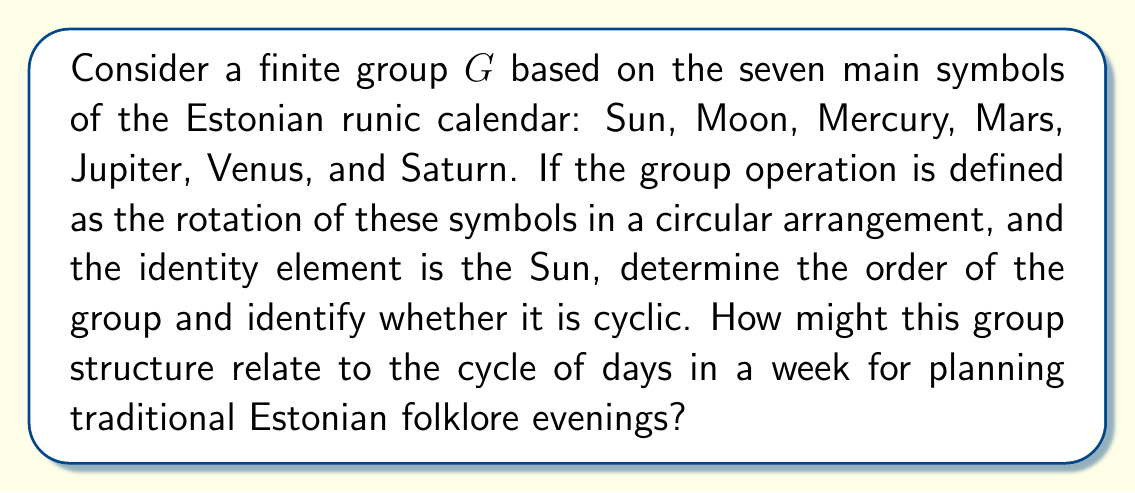Provide a solution to this math problem. To analyze this group structure:

1) First, we need to understand the elements of the group. We have 7 elements corresponding to the celestial bodies: 
   $G = \{Sun, Moon, Mercury, Mars, Jupiter, Venus, Saturn\}$

2) The group operation is rotation in a circular arrangement. This means that each element, when applied, shifts the arrangement by one position.

3) Let's define the generator of the group as $a$, where $a$ represents a single rotation. Then:
   $a^1 = Moon$
   $a^2 = Mercury$
   $a^3 = Mars$
   $a^4 = Jupiter$
   $a^5 = Venus$
   $a^6 = Saturn$
   $a^7 = Sun$ (back to the identity)

4) The order of the group is the number of unique elements, which is 7.

5) To determine if the group is cyclic, we need to check if there's an element that generates all other elements. In this case, $a$ (single rotation) generates all elements:
   $\langle a \rangle = \{a^0, a^1, a^2, a^3, a^4, a^5, a^6\} = G$

6) Therefore, the group is cyclic.

7) This group structure directly relates to the cycle of days in a week. Each day can be associated with one of these celestial bodies, forming a repeating 7-day cycle. This aligns perfectly with planning weekly folklore evenings in an Estonian restaurant, where each day could feature themes or stories related to the associated celestial body.
Answer: The order of the group is 7, and it is a cyclic group. This structure corresponds to the 7-day week cycle, which can be utilized for planning themed Estonian folklore evenings based on the celestial body associated with each day. 